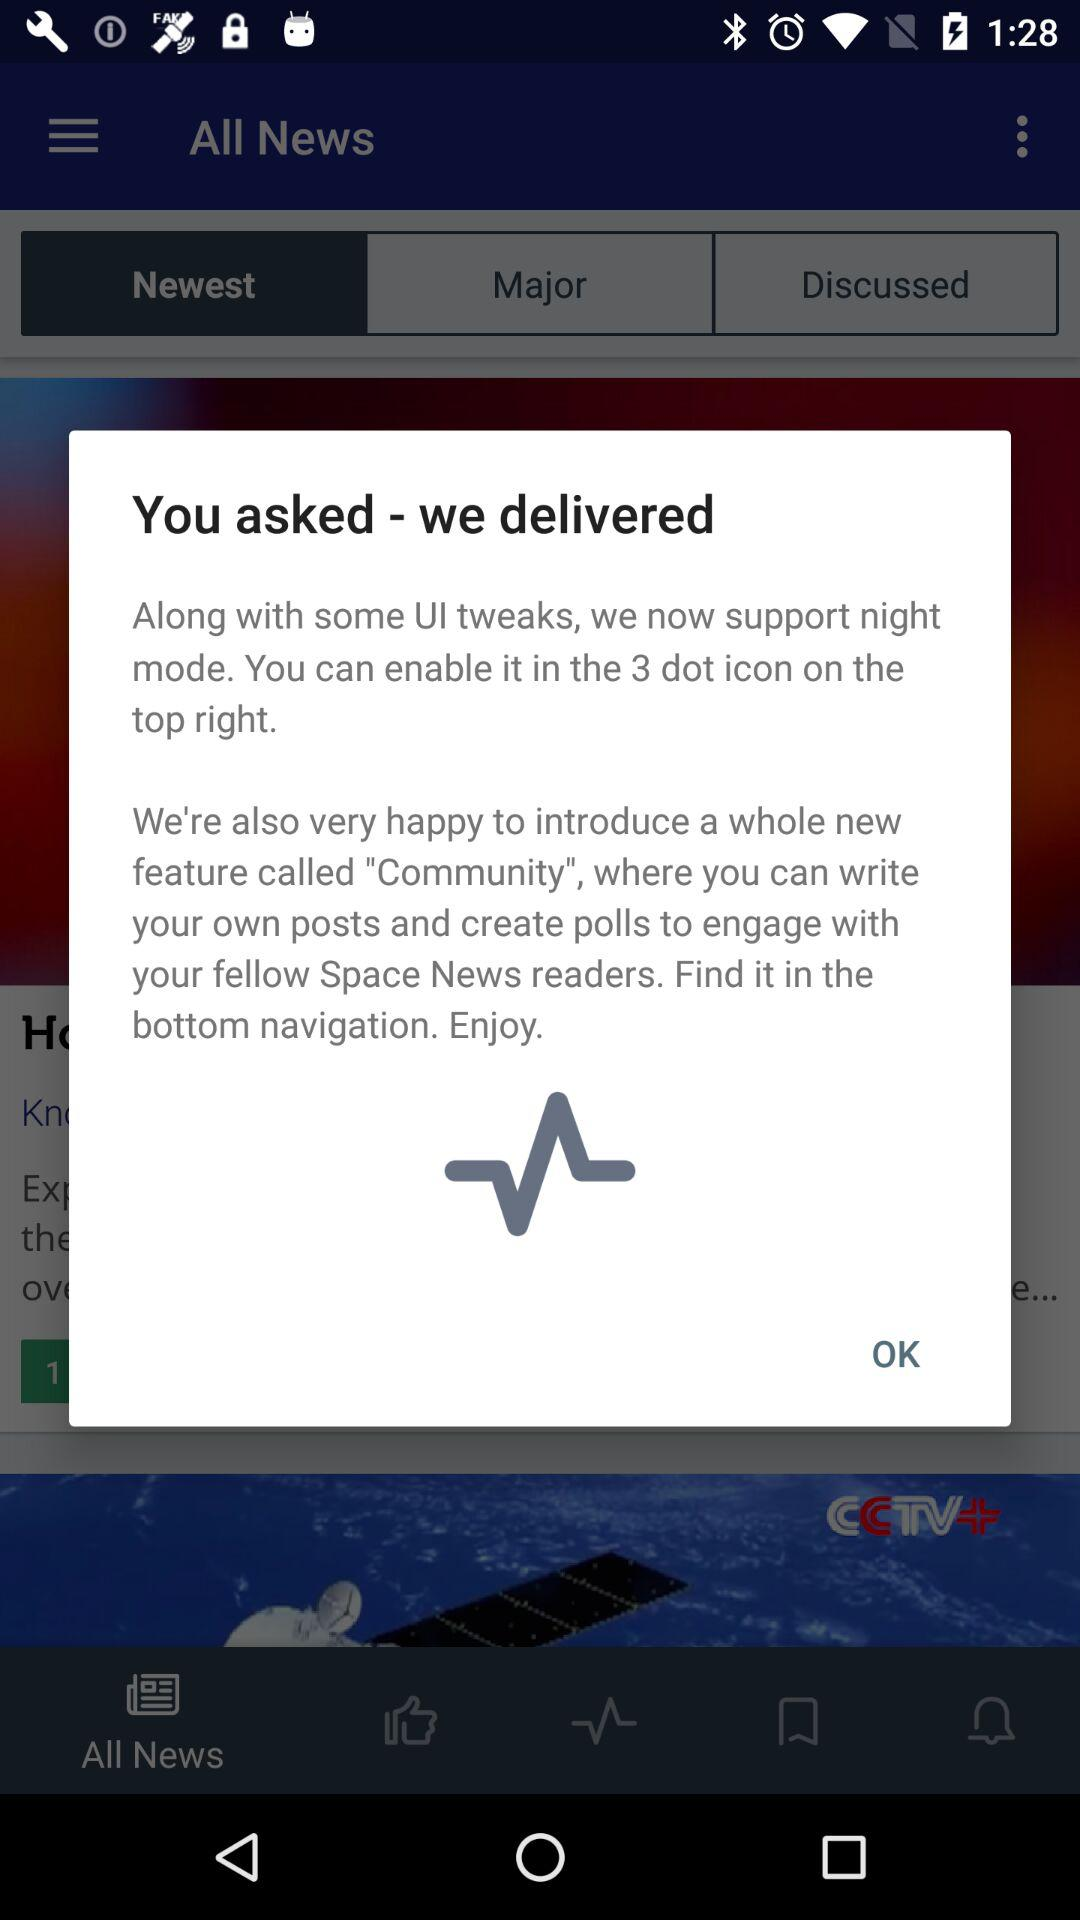How many positive reviews does the application have?
When the provided information is insufficient, respond with <no answer>. <no answer> 